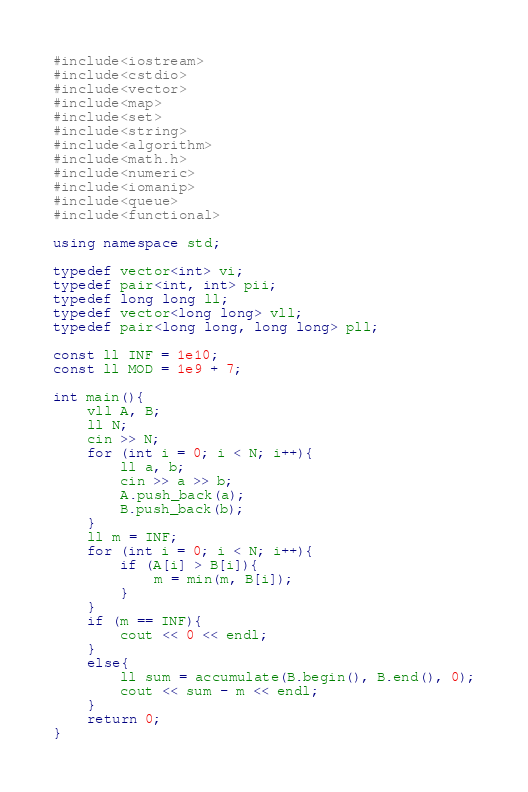Convert code to text. <code><loc_0><loc_0><loc_500><loc_500><_C++_>#include<iostream>
#include<cstdio>
#include<vector>
#include<map>
#include<set>
#include<string>
#include<algorithm>
#include<math.h>
#include<numeric>
#include<iomanip>
#include<queue>
#include<functional>

using namespace std;

typedef vector<int> vi;
typedef pair<int, int> pii;
typedef long long ll;
typedef vector<long long> vll;
typedef pair<long long, long long> pll;

const ll INF = 1e10;
const ll MOD = 1e9 + 7;

int main(){
	vll A, B;
	ll N;
	cin >> N;
	for (int i = 0; i < N; i++){
		ll a, b;
		cin >> a >> b;
		A.push_back(a);
		B.push_back(b);
	}
	ll m = INF;
	for (int i = 0; i < N; i++){
		if (A[i] > B[i]){
			m = min(m, B[i]);
		}
	}
	if (m == INF){
		cout << 0 << endl;
	}
	else{
		ll sum = accumulate(B.begin(), B.end(), 0);
		cout << sum - m << endl;
	}
	return 0;
}
</code> 